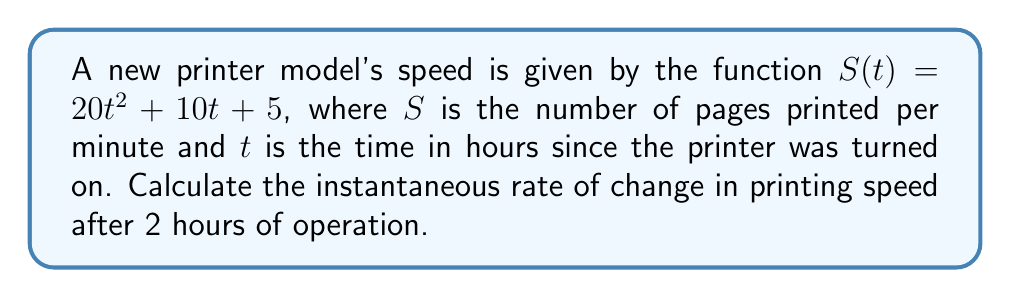What is the answer to this math problem? To find the instantaneous rate of change in printing speed, we need to calculate the derivative of the speed function $S(t)$ and evaluate it at $t = 2$ hours.

Step 1: Find the derivative of $S(t)$
$$\frac{d}{dt}S(t) = \frac{d}{dt}(20t^2 + 10t + 5)$$
$$S'(t) = 40t + 10$$

Step 2: Evaluate the derivative at $t = 2$
$$S'(2) = 40(2) + 10$$
$$S'(2) = 80 + 10 = 90$$

The instantaneous rate of change in printing speed after 2 hours of operation is 90 pages per minute per hour.
Answer: 90 pages/minute/hour 